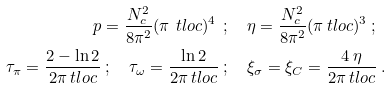<formula> <loc_0><loc_0><loc_500><loc_500>p = \frac { N _ { c } ^ { 2 } } { 8 \pi ^ { 2 } } ( \pi \ t l o c ) ^ { 4 } \ & ; \quad \eta = \frac { N _ { c } ^ { 2 } } { 8 \pi ^ { 2 } } ( \pi \ t l o c ) ^ { 3 } \ ; \\ \quad \tau _ { \pi } = \frac { 2 - \ln 2 } { 2 \pi \ t l o c } \ ; \quad \tau _ { \omega } = \frac { \ln 2 } { 2 \pi \ t l o c } \ & ; \quad \xi _ { \sigma } = \xi _ { C } = \frac { 4 \ \eta } { 2 \pi \ t l o c } \ .</formula> 